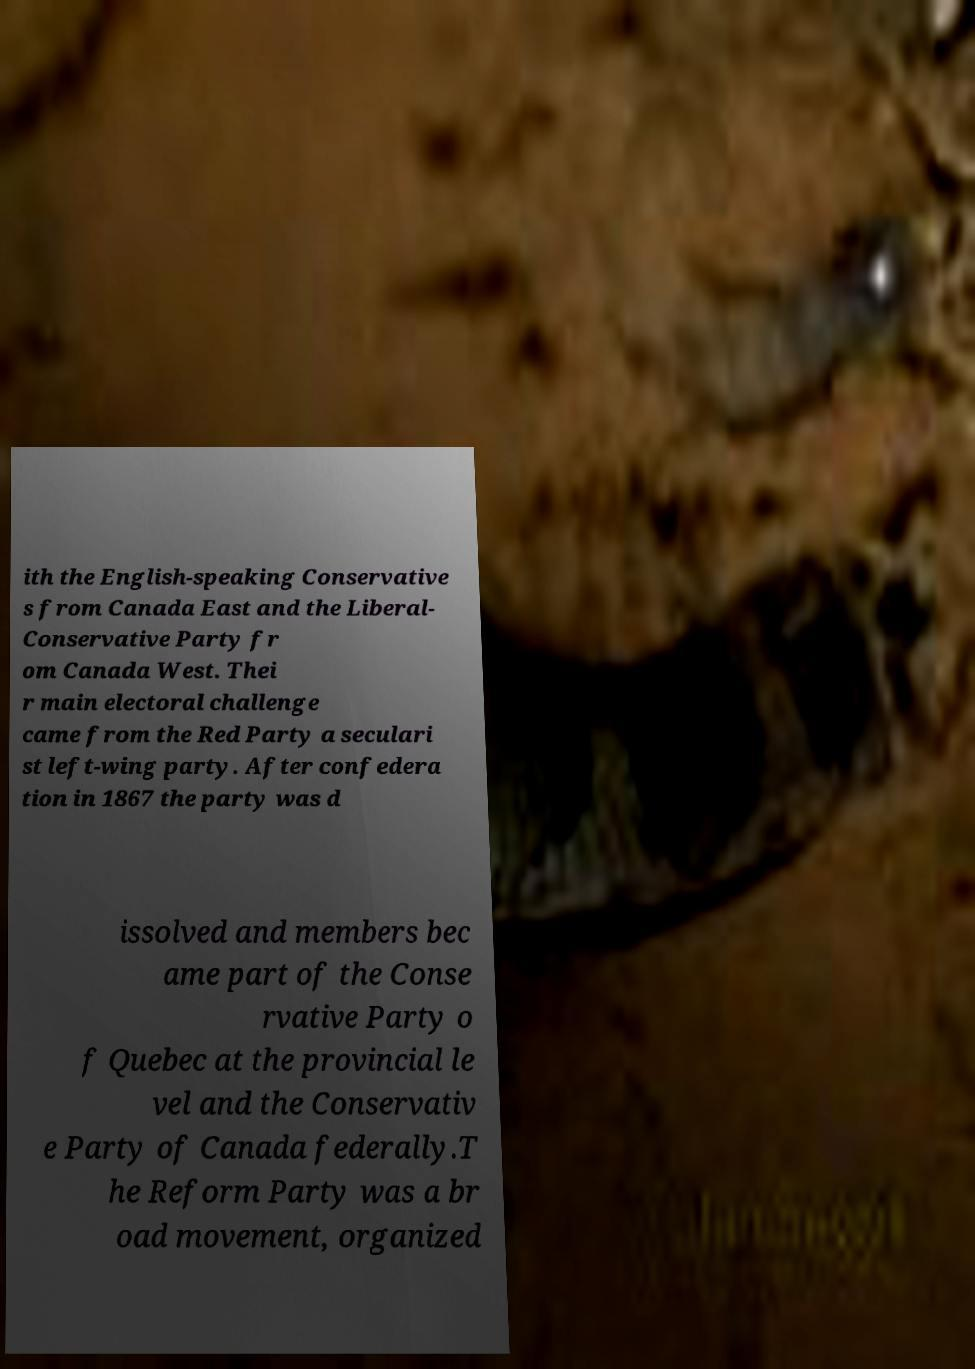For documentation purposes, I need the text within this image transcribed. Could you provide that? ith the English-speaking Conservative s from Canada East and the Liberal- Conservative Party fr om Canada West. Thei r main electoral challenge came from the Red Party a seculari st left-wing party. After confedera tion in 1867 the party was d issolved and members bec ame part of the Conse rvative Party o f Quebec at the provincial le vel and the Conservativ e Party of Canada federally.T he Reform Party was a br oad movement, organized 